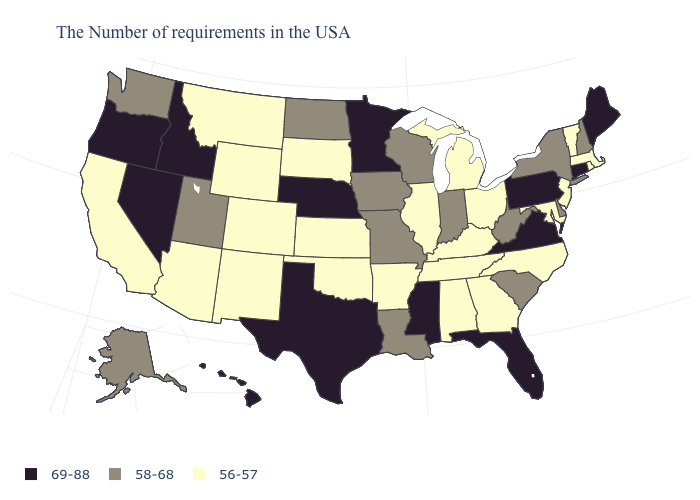What is the lowest value in the USA?
Answer briefly. 56-57. Name the states that have a value in the range 56-57?
Answer briefly. Massachusetts, Rhode Island, Vermont, New Jersey, Maryland, North Carolina, Ohio, Georgia, Michigan, Kentucky, Alabama, Tennessee, Illinois, Arkansas, Kansas, Oklahoma, South Dakota, Wyoming, Colorado, New Mexico, Montana, Arizona, California. Does Wyoming have the lowest value in the West?
Concise answer only. Yes. Does Texas have the highest value in the USA?
Quick response, please. Yes. Name the states that have a value in the range 58-68?
Answer briefly. New Hampshire, New York, Delaware, South Carolina, West Virginia, Indiana, Wisconsin, Louisiana, Missouri, Iowa, North Dakota, Utah, Washington, Alaska. What is the value of Oregon?
Give a very brief answer. 69-88. Among the states that border Illinois , does Kentucky have the lowest value?
Short answer required. Yes. What is the highest value in states that border Montana?
Short answer required. 69-88. Does North Carolina have a lower value than Montana?
Answer briefly. No. Name the states that have a value in the range 56-57?
Give a very brief answer. Massachusetts, Rhode Island, Vermont, New Jersey, Maryland, North Carolina, Ohio, Georgia, Michigan, Kentucky, Alabama, Tennessee, Illinois, Arkansas, Kansas, Oklahoma, South Dakota, Wyoming, Colorado, New Mexico, Montana, Arizona, California. What is the value of New Jersey?
Keep it brief. 56-57. Does California have the lowest value in the West?
Answer briefly. Yes. What is the value of Georgia?
Answer briefly. 56-57. What is the highest value in the USA?
Quick response, please. 69-88. 